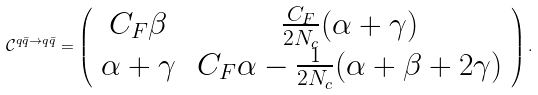Convert formula to latex. <formula><loc_0><loc_0><loc_500><loc_500>\mathcal { C } ^ { q \bar { q } \rightarrow q \bar { q } } = \left ( \begin{array} [ c ] { c c } C _ { F } \beta \, & \frac { C _ { F } } { 2 N _ { c } } ( \alpha + \gamma ) \\ \alpha + \gamma \, & C _ { F } \alpha - \frac { 1 } { 2 N _ { c } } ( \alpha + \beta + 2 \gamma ) \end{array} \right ) .</formula> 